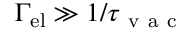<formula> <loc_0><loc_0><loc_500><loc_500>\Gamma _ { e l } \gg 1 / \tau _ { v a c }</formula> 